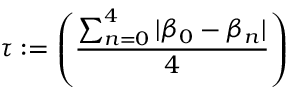Convert formula to latex. <formula><loc_0><loc_0><loc_500><loc_500>\tau \colon = \left ( \frac { \sum _ { n = 0 } ^ { 4 } | \beta _ { 0 } - \beta _ { n } | } { 4 } \right )</formula> 